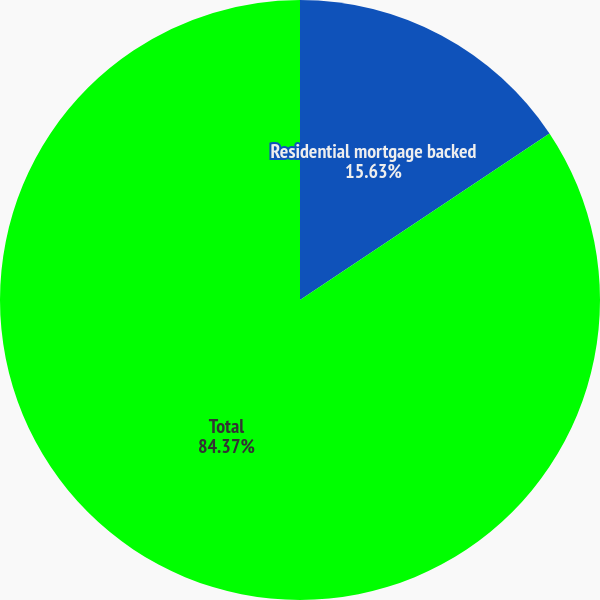<chart> <loc_0><loc_0><loc_500><loc_500><pie_chart><fcel>Residential mortgage backed<fcel>Total<nl><fcel>15.63%<fcel>84.37%<nl></chart> 